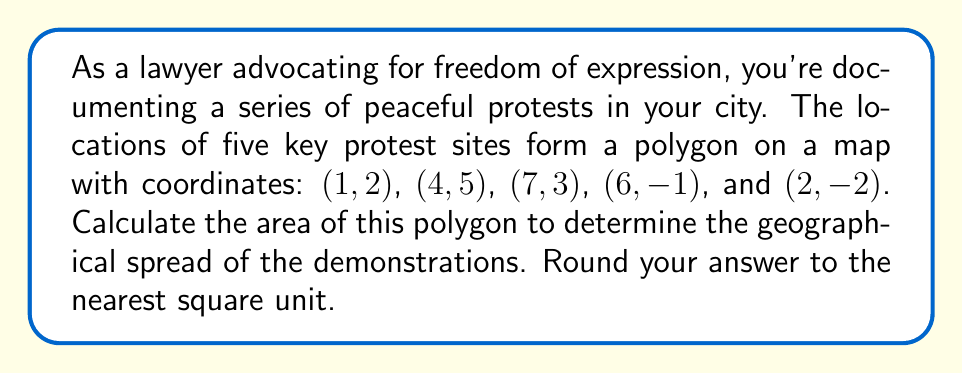Teach me how to tackle this problem. To find the area of an irregular polygon given its vertices, we can use the Shoelace formula (also known as the surveyor's formula). The steps are as follows:

1) First, let's arrange the coordinates in order, repeating the first coordinate at the end:
   $(x_1, y_1) = (1, 2)$
   $(x_2, y_2) = (4, 5)$
   $(x_3, y_3) = (7, 3)$
   $(x_4, y_4) = (6, -1)$
   $(x_5, y_5) = (2, -2)$
   $(x_6, y_6) = (1, 2)$ (repeating the first point)

2) The Shoelace formula is:

   $$A = \frac{1}{2}|(x_1y_2 + x_2y_3 + x_3y_4 + x_4y_5 + x_5y_6) - (y_1x_2 + y_2x_3 + y_3x_4 + y_4x_5 + y_5x_6)|$$

3) Let's substitute the values:

   $$A = \frac{1}{2}|(1 \cdot 5 + 4 \cdot 3 + 7 \cdot (-1) + 6 \cdot (-2) + 2 \cdot 2) - (2 \cdot 4 + 5 \cdot 7 + 3 \cdot 6 + (-1) \cdot 2 + (-2) \cdot 1)|$$

4) Simplify:

   $$A = \frac{1}{2}|(5 + 12 - 7 - 12 + 4) - (8 + 35 + 18 - 2 - 2)|$$
   
   $$A = \frac{1}{2}|2 - 57|$$
   
   $$A = \frac{1}{2}|-55|$$
   
   $$A = \frac{55}{2} = 27.5$$

5) Rounding to the nearest square unit:

   $A \approx 28$ square units
Answer: 28 square units 